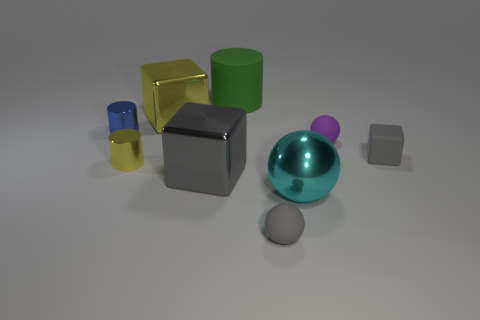There is a large object to the right of the big green matte cylinder; does it have the same color as the small block?
Your answer should be compact. No. How many matte balls are the same size as the blue thing?
Provide a short and direct response. 2. What shape is the large green thing that is the same material as the tiny gray block?
Provide a short and direct response. Cylinder. Is there a large metallic sphere that has the same color as the rubber block?
Provide a succinct answer. No. What material is the big gray object?
Your response must be concise. Metal. How many objects are large metal balls or large gray metallic things?
Ensure brevity in your answer.  2. There is a metal object right of the large green object; what is its size?
Give a very brief answer. Large. How many other things are there of the same material as the yellow cylinder?
Make the answer very short. 4. There is a blue metal thing to the left of the large yellow shiny block; are there any large gray metal cubes to the left of it?
Give a very brief answer. No. Is there any other thing that has the same shape as the cyan object?
Give a very brief answer. Yes. 